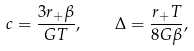<formula> <loc_0><loc_0><loc_500><loc_500>c = \frac { 3 r _ { + } \beta } { G T } , \quad \Delta = \frac { r _ { + } T } { 8 G \beta } ,</formula> 